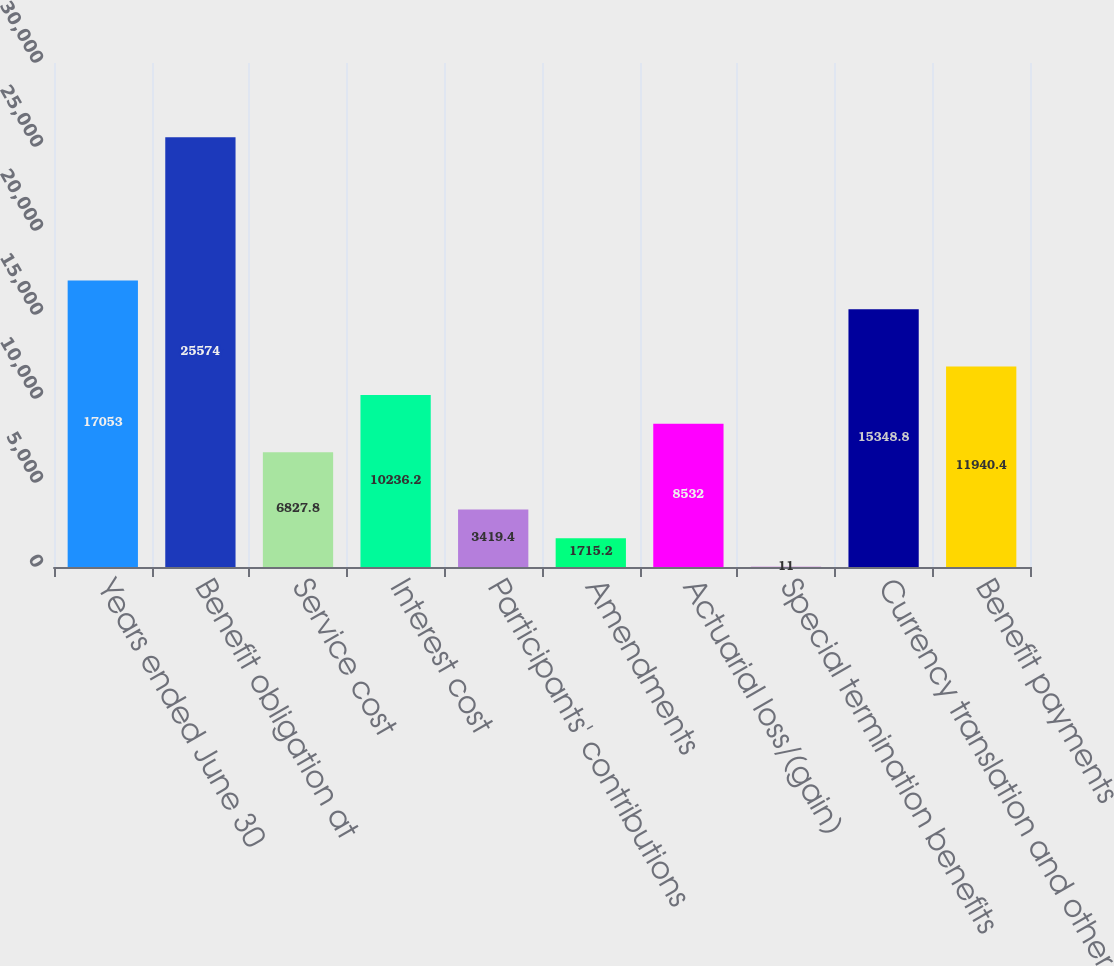Convert chart. <chart><loc_0><loc_0><loc_500><loc_500><bar_chart><fcel>Years ended June 30<fcel>Benefit obligation at<fcel>Service cost<fcel>Interest cost<fcel>Participants' contributions<fcel>Amendments<fcel>Actuarial loss/(gain)<fcel>Special termination benefits<fcel>Currency translation and other<fcel>Benefit payments<nl><fcel>17053<fcel>25574<fcel>6827.8<fcel>10236.2<fcel>3419.4<fcel>1715.2<fcel>8532<fcel>11<fcel>15348.8<fcel>11940.4<nl></chart> 